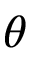Convert formula to latex. <formula><loc_0><loc_0><loc_500><loc_500>\theta</formula> 